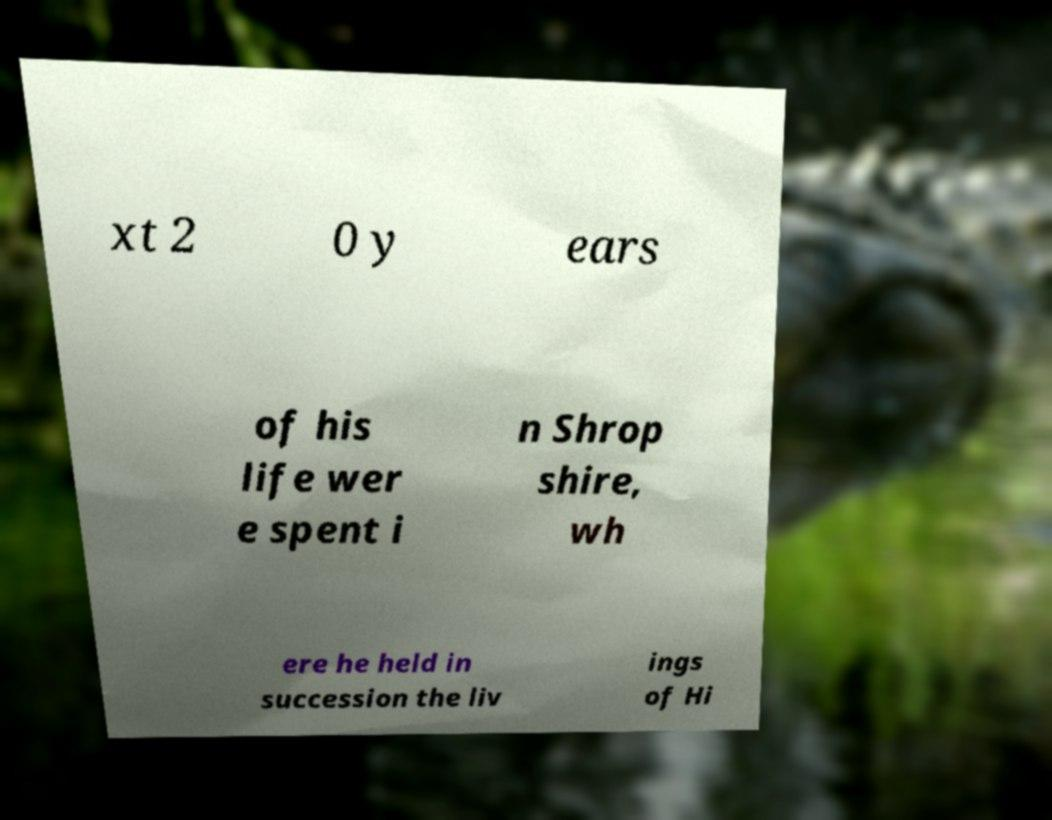Please identify and transcribe the text found in this image. xt 2 0 y ears of his life wer e spent i n Shrop shire, wh ere he held in succession the liv ings of Hi 